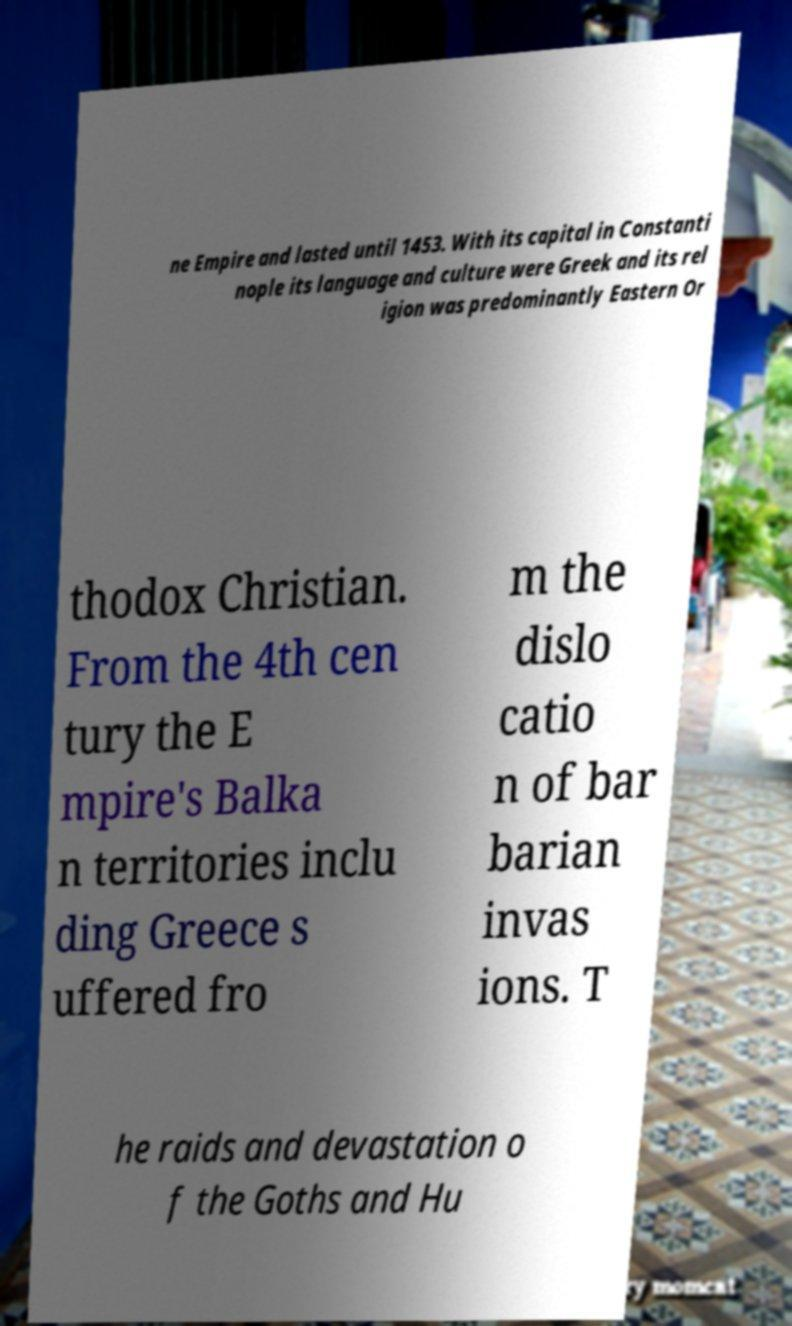Please identify and transcribe the text found in this image. ne Empire and lasted until 1453. With its capital in Constanti nople its language and culture were Greek and its rel igion was predominantly Eastern Or thodox Christian. From the 4th cen tury the E mpire's Balka n territories inclu ding Greece s uffered fro m the dislo catio n of bar barian invas ions. T he raids and devastation o f the Goths and Hu 